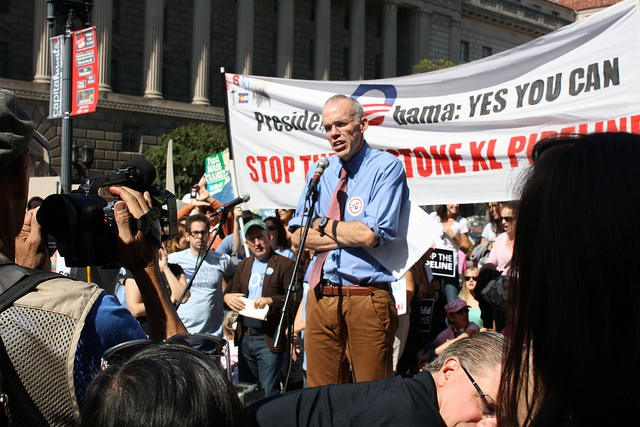Describe the objects in this image and their specific colors. I can see people in black, maroon, and gray tones, people in black, gray, tan, and darkgray tones, people in black, maroon, lightblue, and brown tones, people in black, tan, and gray tones, and people in black and gray tones in this image. 